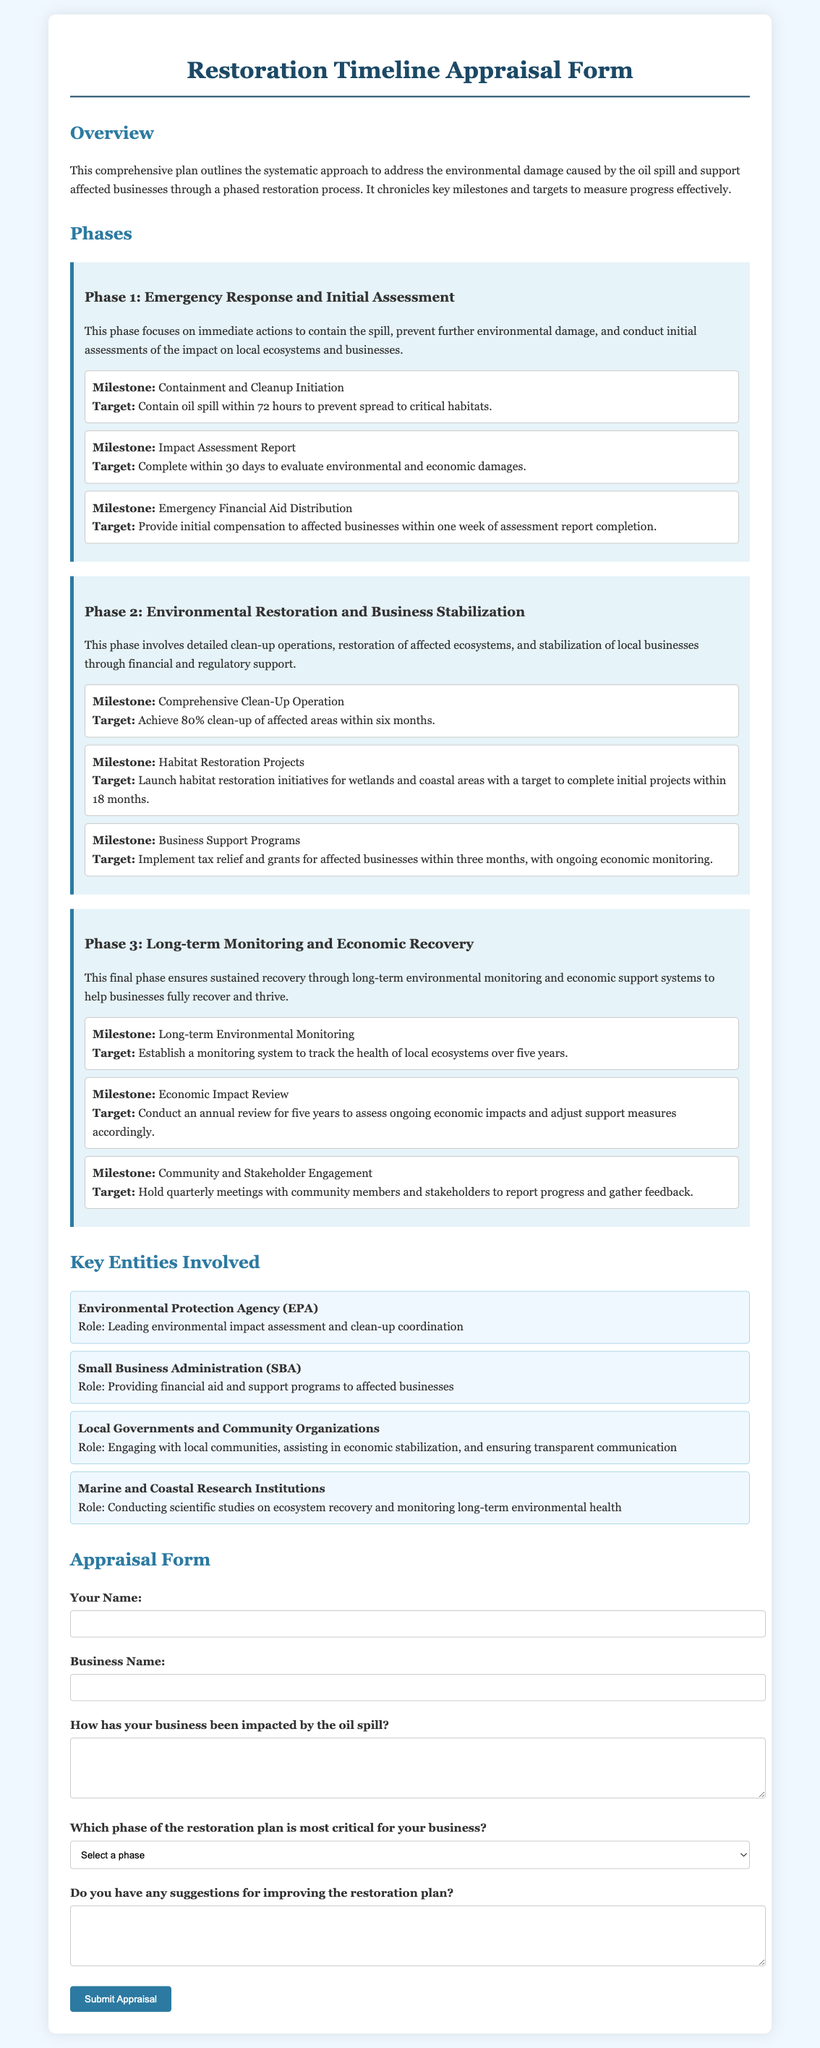What is the title of the document? The title, prominently displayed at the top of the document, indicates the subject matter it covers.
Answer: Restoration Timeline Appraisal Form How many phases are outlined in the restoration plan? The document includes a structured description of the restoration process, mentioning specific phases.
Answer: Three What is the target for the initial impact assessment report? The document specifies a time frame for completing the impact assessment, which is crucial for planning subsequent actions.
Answer: 30 days What is the milestone for the comprehensive clean-up operation? The document details specific targets related to clean-up efforts in the second phase.
Answer: Achieve 80% clean-up Which entity is responsible for leading environmental impact assessments? The document lists key entities and their roles in the restoration effort.
Answer: Environmental Protection Agency (EPA) What is the target for community engagement meetings? The document describes how often community engagement efforts are planned, which helps in maintaining transparency and accountability.
Answer: Quarterly In which phase should emergency financial aid be distributed? The document specifies when initial financing assistance is expected to begin, highlighting its importance in the response effort.
Answer: Phase 1 What is the goal for habitat restoration initiatives? The document outlines specific objectives for restoring affected habitats and ecosystems.
Answer: Complete initial projects within 18 months What type of support is included for affected businesses in Phase 2? The document describes specific financial measures aimed at help stabilizing local businesses during the restoration process.
Answer: Tax relief and grants 